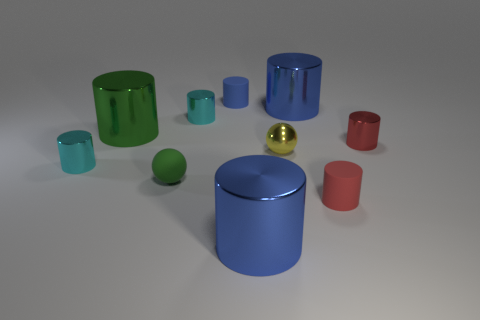How many blue cylinders must be subtracted to get 1 blue cylinders? 2 Subtract all red blocks. How many blue cylinders are left? 3 Subtract 5 cylinders. How many cylinders are left? 3 Subtract all blue cylinders. How many cylinders are left? 5 Subtract all big green shiny cylinders. How many cylinders are left? 7 Subtract all gray cylinders. Subtract all yellow spheres. How many cylinders are left? 8 Subtract all cylinders. How many objects are left? 2 Add 1 blue metallic objects. How many blue metallic objects are left? 3 Add 1 blue things. How many blue things exist? 4 Subtract 0 yellow cylinders. How many objects are left? 10 